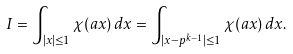<formula> <loc_0><loc_0><loc_500><loc_500>I = \int _ { | x | \leq 1 } \chi ( a x ) \, d x = \int _ { | x - p ^ { k - 1 } | \leq 1 } \chi ( a x ) \, d x .</formula> 